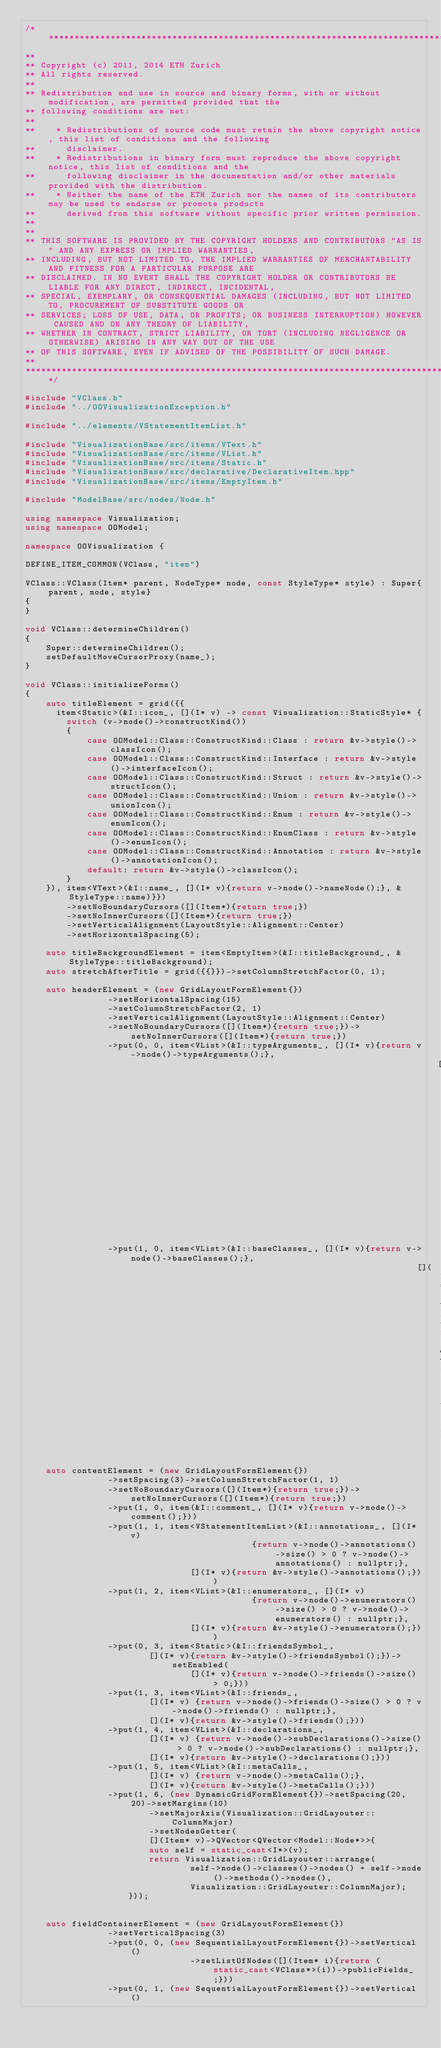Convert code to text. <code><loc_0><loc_0><loc_500><loc_500><_C++_>/***********************************************************************************************************************
**
** Copyright (c) 2011, 2014 ETH Zurich
** All rights reserved.
**
** Redistribution and use in source and binary forms, with or without modification, are permitted provided that the
** following conditions are met:
**
**    * Redistributions of source code must retain the above copyright notice, this list of conditions and the following
**      disclaimer.
**    * Redistributions in binary form must reproduce the above copyright notice, this list of conditions and the
**      following disclaimer in the documentation and/or other materials provided with the distribution.
**    * Neither the name of the ETH Zurich nor the names of its contributors may be used to endorse or promote products
**      derived from this software without specific prior written permission.
**
**
** THIS SOFTWARE IS PROVIDED BY THE COPYRIGHT HOLDERS AND CONTRIBUTORS "AS IS" AND ANY EXPRESS OR IMPLIED WARRANTIES,
** INCLUDING, BUT NOT LIMITED TO, THE IMPLIED WARRANTIES OF MERCHANTABILITY AND FITNESS FOR A PARTICULAR PURPOSE ARE
** DISCLAIMED. IN NO EVENT SHALL THE COPYRIGHT HOLDER OR CONTRIBUTORS BE LIABLE FOR ANY DIRECT, INDIRECT, INCIDENTAL,
** SPECIAL, EXEMPLARY, OR CONSEQUENTIAL DAMAGES (INCLUDING, BUT NOT LIMITED TO, PROCUREMENT OF SUBSTITUTE GOODS OR
** SERVICES; LOSS OF USE, DATA, OR PROFITS; OR BUSINESS INTERRUPTION) HOWEVER CAUSED AND ON ANY THEORY OF LIABILITY,
** WHETHER IN CONTRACT, STRICT LIABILITY, OR TORT (INCLUDING NEGLIGENCE OR OTHERWISE) ARISING IN ANY WAY OUT OF THE USE
** OF THIS SOFTWARE, EVEN IF ADVISED OF THE POSSIBILITY OF SUCH DAMAGE.
**
***********************************************************************************************************************/

#include "VClass.h"
#include "../OOVisualizationException.h"

#include "../elements/VStatementItemList.h"

#include "VisualizationBase/src/items/VText.h"
#include "VisualizationBase/src/items/VList.h"
#include "VisualizationBase/src/items/Static.h"
#include "VisualizationBase/src/declarative/DeclarativeItem.hpp"
#include "VisualizationBase/src/items/EmptyItem.h"

#include "ModelBase/src/nodes/Node.h"

using namespace Visualization;
using namespace OOModel;

namespace OOVisualization {

DEFINE_ITEM_COMMON(VClass, "item")

VClass::VClass(Item* parent, NodeType* node, const StyleType* style) : Super{parent, node, style}
{
}

void VClass::determineChildren()
{
	Super::determineChildren();
	setDefaultMoveCursorProxy(name_);
}

void VClass::initializeForms()
{
	auto titleElement = grid({{
	  item<Static>(&I::icon_, [](I* v) -> const Visualization::StaticStyle* {
		switch (v->node()->constructKind())
		{
			case OOModel::Class::ConstructKind::Class : return &v->style()->classIcon();
			case OOModel::Class::ConstructKind::Interface : return &v->style()->interfaceIcon();
			case OOModel::Class::ConstructKind::Struct : return &v->style()->structIcon();
			case OOModel::Class::ConstructKind::Union : return &v->style()->unionIcon();
			case OOModel::Class::ConstructKind::Enum : return &v->style()->enumIcon();
			case OOModel::Class::ConstructKind::EnumClass : return &v->style()->enumIcon();
			case OOModel::Class::ConstructKind::Annotation : return &v->style()->annotationIcon();
			default: return &v->style()->classIcon();
		}
	}), item<VText>(&I::name_, [](I* v){return v->node()->nameNode();}, &StyleType::name)}})
		->setNoBoundaryCursors([](Item*){return true;})
		->setNoInnerCursors([](Item*){return true;})
		->setVerticalAlignment(LayoutStyle::Alignment::Center)
		->setHorizontalSpacing(5);

	auto titleBackgroundElement = item<EmptyItem>(&I::titleBackground_, &StyleType::titleBackground);
	auto stretchAfterTitle = grid({{}})->setColumnStretchFactor(0, 1);

	auto headerElement = (new GridLayoutFormElement{})
				->setHorizontalSpacing(15)
				->setColumnStretchFactor(2, 1)
				->setVerticalAlignment(LayoutStyle::Alignment::Center)
				->setNoBoundaryCursors([](Item*){return true;})->setNoInnerCursors([](Item*){return true;})
				->put(0, 0, item<VList>(&I::typeArguments_, [](I* v){return v->node()->typeArguments();},
																				[](I* v){return &v->style()->typeArguments();}))
				->put(1, 0, item<VList>(&I::baseClasses_, [](I* v){return v->node()->baseClasses();},
																			[](I* v){return &v->style()->baseClasses();}));

	auto contentElement = (new GridLayoutFormElement{})
				->setSpacing(3)->setColumnStretchFactor(1, 1)
				->setNoBoundaryCursors([](Item*){return true;})->setNoInnerCursors([](Item*){return true;})
				->put(1, 0, item(&I::comment_, [](I* v){return v->node()->comment();}))
				->put(1, 1, item<VStatementItemList>(&I::annotations_, [](I* v)
											{return v->node()->annotations()->size() > 0 ? v->node()->annotations() : nullptr;},
								[](I* v){return &v->style()->annotations();}))
				->put(1, 2, item<VList>(&I::enumerators_, [](I* v)
											{return v->node()->enumerators()->size() > 0 ? v->node()->enumerators() : nullptr;},
								[](I* v){return &v->style()->enumerators();}))
				->put(0, 3, item<Static>(&I::friendsSymbol_,
						[](I* v){return &v->style()->friendsSymbol();})->setEnabled(
								[](I* v){return v->node()->friends()->size() > 0;}))
				->put(1, 3, item<VList>(&I::friends_,
						[](I* v) {return v->node()->friends()->size() > 0 ? v->node()->friends() : nullptr;},
						[](I* v){return &v->style()->friends();}))
				->put(1, 4, item<VList>(&I::declarations_,
						[](I* v) {return v->node()->subDeclarations()->size() > 0 ? v->node()->subDeclarations() : nullptr;},
						[](I* v){return &v->style()->declarations();}))
				->put(1, 5, item<VList>(&I::metaCalls_,
						[](I* v) {return v->node()->metaCalls();},
						[](I* v){return &v->style()->metaCalls();}))
				->put(1, 6, (new DynamicGridFormElement{})->setSpacing(20, 20)->setMargins(10)
						->setMajorAxis(Visualization::GridLayouter::ColumnMajor)
						->setNodesGetter(
						[](Item* v)->QVector<QVector<Model::Node*>>{
						auto self = static_cast<I*>(v);
						return Visualization::GridLayouter::arrange(
								self->node()->classes()->nodes() + self->node()->methods()->nodes(),
								Visualization::GridLayouter::ColumnMajor);
					}));


	auto fieldContainerElement = (new GridLayoutFormElement{})
				->setVerticalSpacing(3)
				->put(0, 0, (new SequentialLayoutFormElement{})->setVertical()
								->setListOfNodes([](Item* i){return (static_cast<VClass*>(i))->publicFields_;}))
				->put(0, 1, (new SequentialLayoutFormElement{})->setVertical()</code> 